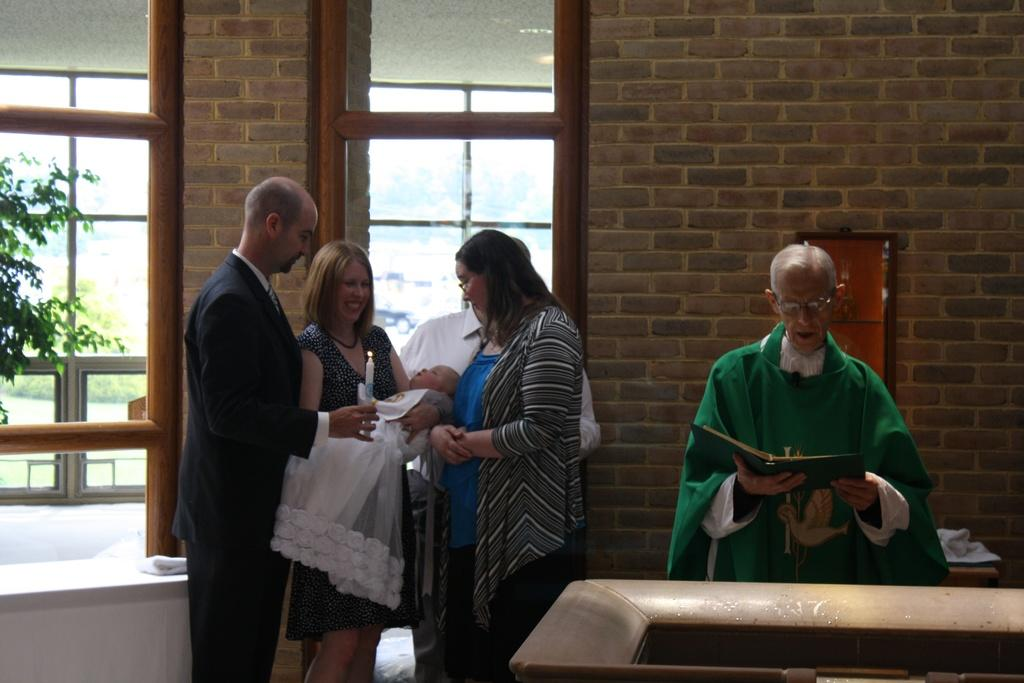How many people are in the image? There is a group of people in the image. What objects are being held by the people in the image? One person is holding a candle, and another person is holding a book. What can be seen in the background of the image? There is a wall, windows, and trees in the background of the image. What type of canvas is being used to create the smoke in the image? There is no canvas or smoke present in the image. What historical event is being depicted in the image? The image does not depict any specific historical event. 